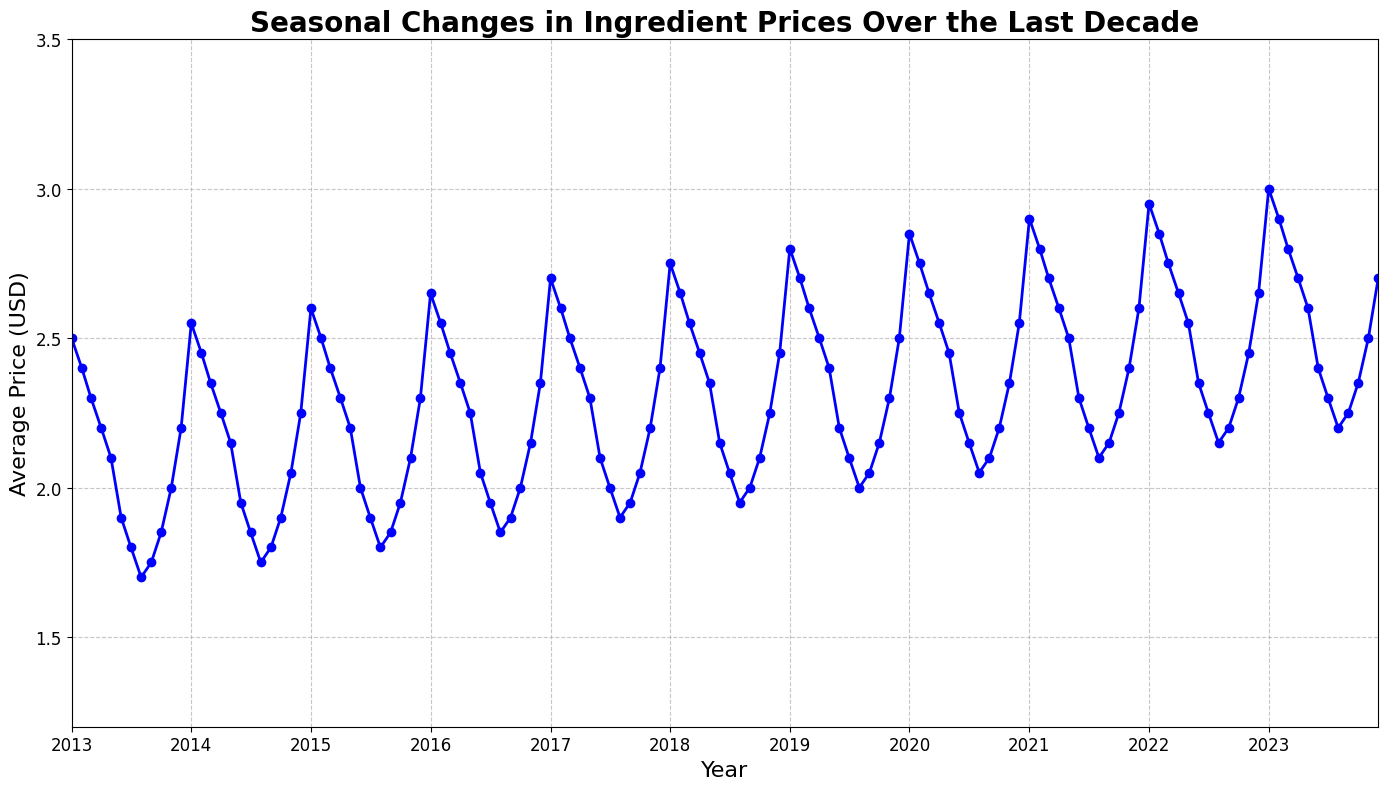What is the trend in the average price of tomatoes from January to December over the last decade? To understand the trend, look at the line chart from January to December for each year. Observe how the price begins higher at the start of the year, dips lower around the middle, and then rises again towards the end.
Answer: The price generally decreases in the middle months and increases towards the end of the year In which years did the average price of tomatoes exceed $2.50 at any point? Look for years where the line chart shows data points above the $2.50 mark. Check the y-axis for the $2.50 level and see in which years the line crosses this level.
Answer: 2019, 2020, 2021, 2022, 2023 What is the difference between the highest and lowest average price recorded in the last decade? Identify the highest peak and the lowest trough in the line chart. Subtract the lowest price from the highest price to find the difference.
Answer: $1.30 During which months did the average tomato price usually reach its minimum? Observe the line chart to identify the months where the price frequently dips to the lowest point. Examine the recurring lowest points across different years.
Answer: July and August How does the average price in December 2022 compare to January 2022? Locate the data points for December 2022 and January 2022 on the line chart, then compare their prices to see which is higher.
Answer: December 2022 is higher What is the average price of tomatoes in June across all the years? To determine the average price in June, take the price values for June from each year, sum them up, and divide by the number of years.
Answer: $2.10 What is the greatest annual increase in the average price of tomatoes from one January to the next January? Identify the price in January for each year and calculate the difference from the previous January. The greatest positive difference will be the largest increase.
Answer: $0.15 (2022 to 2023) Which year experienced the highest average annual price for tomatoes? Calculate the average price for each year by taking the twelve-month prices and find the year with the highest annual average.
Answer: 2023 How much did the price change from August 2020 to September 2020? Locate the data points for August 2020 and September 2020 on the line chart, then calculate the difference between these two prices.
Answer: $0.05 increase During which month and year did the average price of tomatoes hit a decade high? Identify the highest point on the line chart and note the corresponding month and year.
Answer: January 2023 